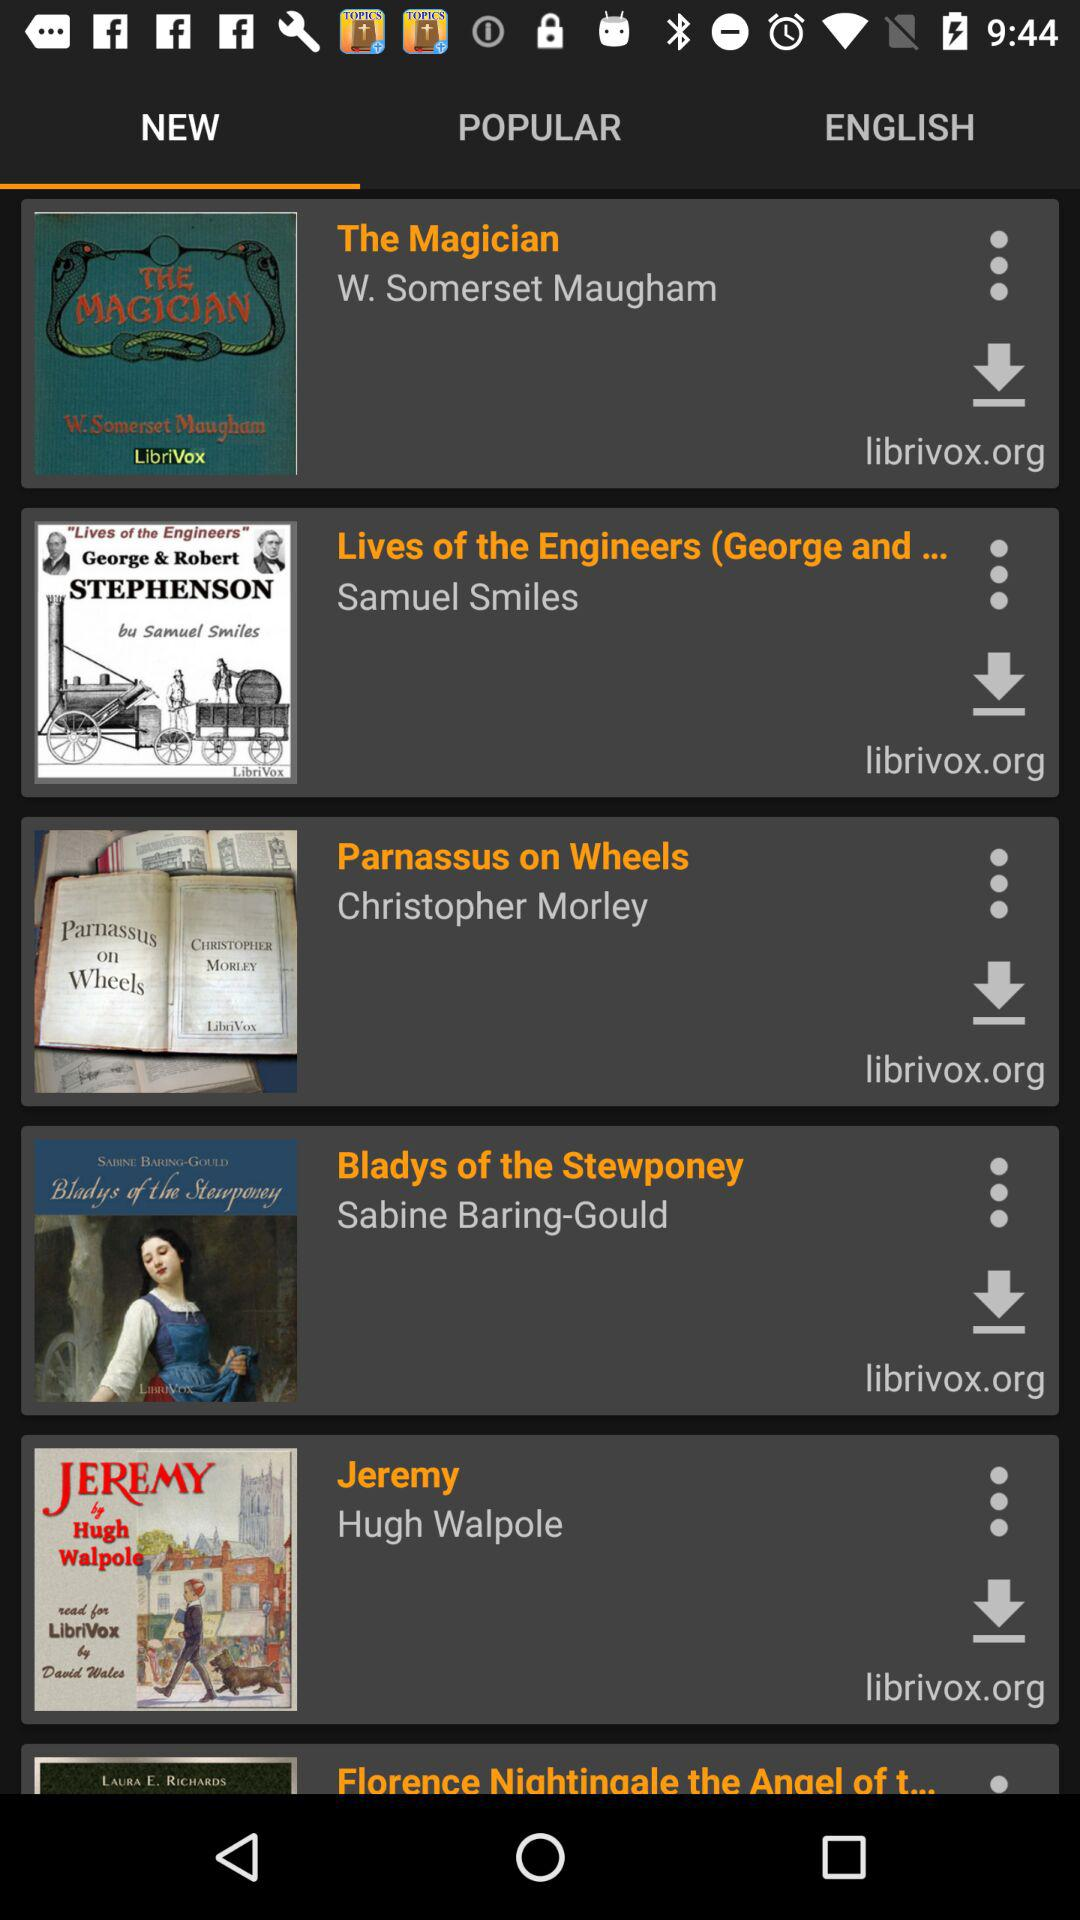Who has written the book "The Magician"? "The Magician" is a book written by W. Somerset Maugham. 